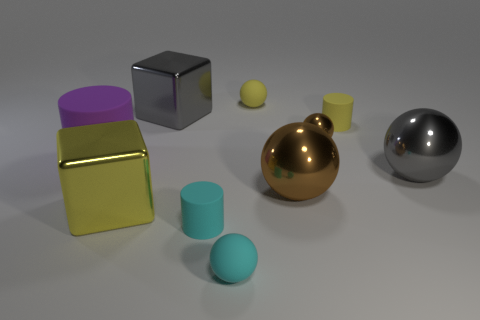Do the rubber cylinder in front of the purple rubber thing and the tiny object in front of the cyan rubber cylinder have the same color?
Provide a short and direct response. Yes. How many things are either tiny cyan metal spheres or metal blocks?
Your response must be concise. 2. How many other objects are the same shape as the purple rubber object?
Give a very brief answer. 2. Is the gray thing in front of the purple rubber cylinder made of the same material as the tiny cylinder in front of the tiny metal sphere?
Your response must be concise. No. The large metal thing that is both behind the large yellow thing and to the left of the small cyan cylinder has what shape?
Give a very brief answer. Cube. Is there anything else that has the same material as the purple cylinder?
Your answer should be compact. Yes. What is the ball that is behind the purple matte object and in front of the yellow sphere made of?
Ensure brevity in your answer.  Metal. There is a large brown object that is the same material as the big yellow block; what is its shape?
Provide a succinct answer. Sphere. Are there any other things of the same color as the large rubber object?
Provide a succinct answer. No. Are there more big gray shiny blocks in front of the yellow metallic block than shiny cubes?
Make the answer very short. No. 